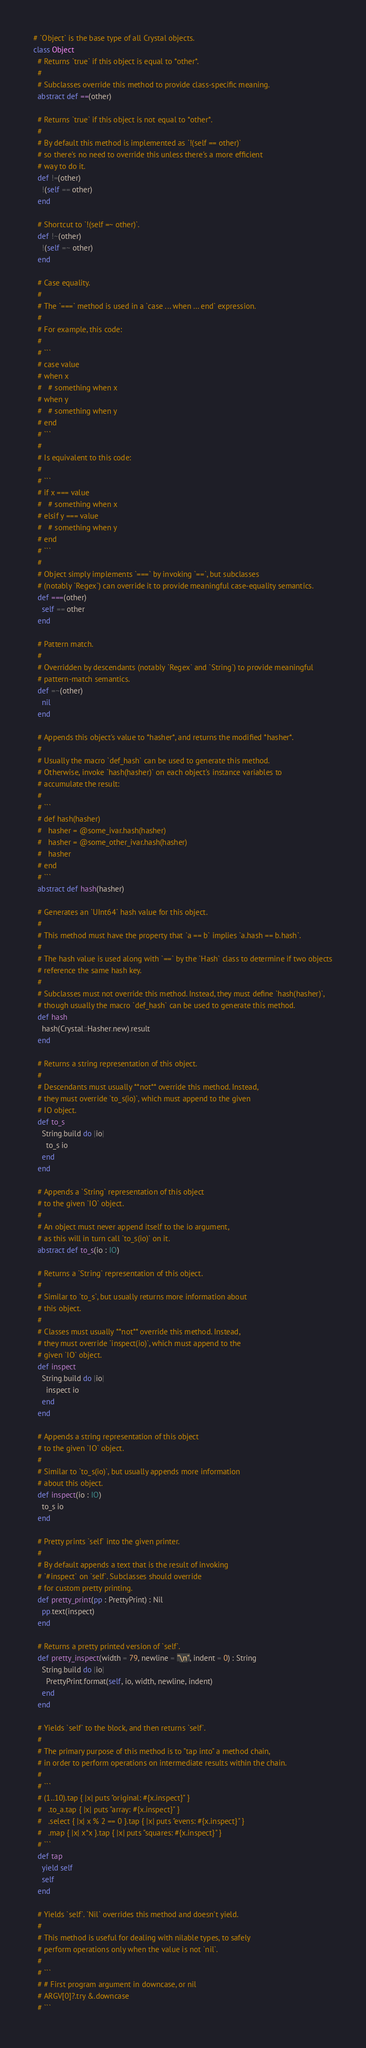<code> <loc_0><loc_0><loc_500><loc_500><_Crystal_># `Object` is the base type of all Crystal objects.
class Object
  # Returns `true` if this object is equal to *other*.
  #
  # Subclasses override this method to provide class-specific meaning.
  abstract def ==(other)

  # Returns `true` if this object is not equal to *other*.
  #
  # By default this method is implemented as `!(self == other)`
  # so there's no need to override this unless there's a more efficient
  # way to do it.
  def !=(other)
    !(self == other)
  end

  # Shortcut to `!(self =~ other)`.
  def !~(other)
    !(self =~ other)
  end

  # Case equality.
  #
  # The `===` method is used in a `case ... when ... end` expression.
  #
  # For example, this code:
  #
  # ```
  # case value
  # when x
  #   # something when x
  # when y
  #   # something when y
  # end
  # ```
  #
  # Is equivalent to this code:
  #
  # ```
  # if x === value
  #   # something when x
  # elsif y === value
  #   # something when y
  # end
  # ```
  #
  # Object simply implements `===` by invoking `==`, but subclasses
  # (notably `Regex`) can override it to provide meaningful case-equality semantics.
  def ===(other)
    self == other
  end

  # Pattern match.
  #
  # Overridden by descendants (notably `Regex` and `String`) to provide meaningful
  # pattern-match semantics.
  def =~(other)
    nil
  end

  # Appends this object's value to *hasher*, and returns the modified *hasher*.
  #
  # Usually the macro `def_hash` can be used to generate this method.
  # Otherwise, invoke `hash(hasher)` on each object's instance variables to
  # accumulate the result:
  #
  # ```
  # def hash(hasher)
  #   hasher = @some_ivar.hash(hasher)
  #   hasher = @some_other_ivar.hash(hasher)
  #   hasher
  # end
  # ```
  abstract def hash(hasher)

  # Generates an `UInt64` hash value for this object.
  #
  # This method must have the property that `a == b` implies `a.hash == b.hash`.
  #
  # The hash value is used along with `==` by the `Hash` class to determine if two objects
  # reference the same hash key.
  #
  # Subclasses must not override this method. Instead, they must define `hash(hasher)`,
  # though usually the macro `def_hash` can be used to generate this method.
  def hash
    hash(Crystal::Hasher.new).result
  end

  # Returns a string representation of this object.
  #
  # Descendants must usually **not** override this method. Instead,
  # they must override `to_s(io)`, which must append to the given
  # IO object.
  def to_s
    String.build do |io|
      to_s io
    end
  end

  # Appends a `String` representation of this object
  # to the given `IO` object.
  #
  # An object must never append itself to the io argument,
  # as this will in turn call `to_s(io)` on it.
  abstract def to_s(io : IO)

  # Returns a `String` representation of this object.
  #
  # Similar to `to_s`, but usually returns more information about
  # this object.
  #
  # Classes must usually **not** override this method. Instead,
  # they must override `inspect(io)`, which must append to the
  # given `IO` object.
  def inspect
    String.build do |io|
      inspect io
    end
  end

  # Appends a string representation of this object
  # to the given `IO` object.
  #
  # Similar to `to_s(io)`, but usually appends more information
  # about this object.
  def inspect(io : IO)
    to_s io
  end

  # Pretty prints `self` into the given printer.
  #
  # By default appends a text that is the result of invoking
  # `#inspect` on `self`. Subclasses should override
  # for custom pretty printing.
  def pretty_print(pp : PrettyPrint) : Nil
    pp.text(inspect)
  end

  # Returns a pretty printed version of `self`.
  def pretty_inspect(width = 79, newline = "\n", indent = 0) : String
    String.build do |io|
      PrettyPrint.format(self, io, width, newline, indent)
    end
  end

  # Yields `self` to the block, and then returns `self`.
  #
  # The primary purpose of this method is to "tap into" a method chain,
  # in order to perform operations on intermediate results within the chain.
  #
  # ```
  # (1..10).tap { |x| puts "original: #{x.inspect}" }
  #   .to_a.tap { |x| puts "array: #{x.inspect}" }
  #   .select { |x| x % 2 == 0 }.tap { |x| puts "evens: #{x.inspect}" }
  #   .map { |x| x*x }.tap { |x| puts "squares: #{x.inspect}" }
  # ```
  def tap
    yield self
    self
  end

  # Yields `self`. `Nil` overrides this method and doesn't yield.
  #
  # This method is useful for dealing with nilable types, to safely
  # perform operations only when the value is not `nil`.
  #
  # ```
  # # First program argument in downcase, or nil
  # ARGV[0]?.try &.downcase
  # ```</code> 